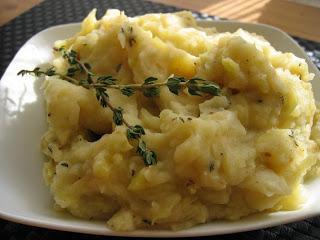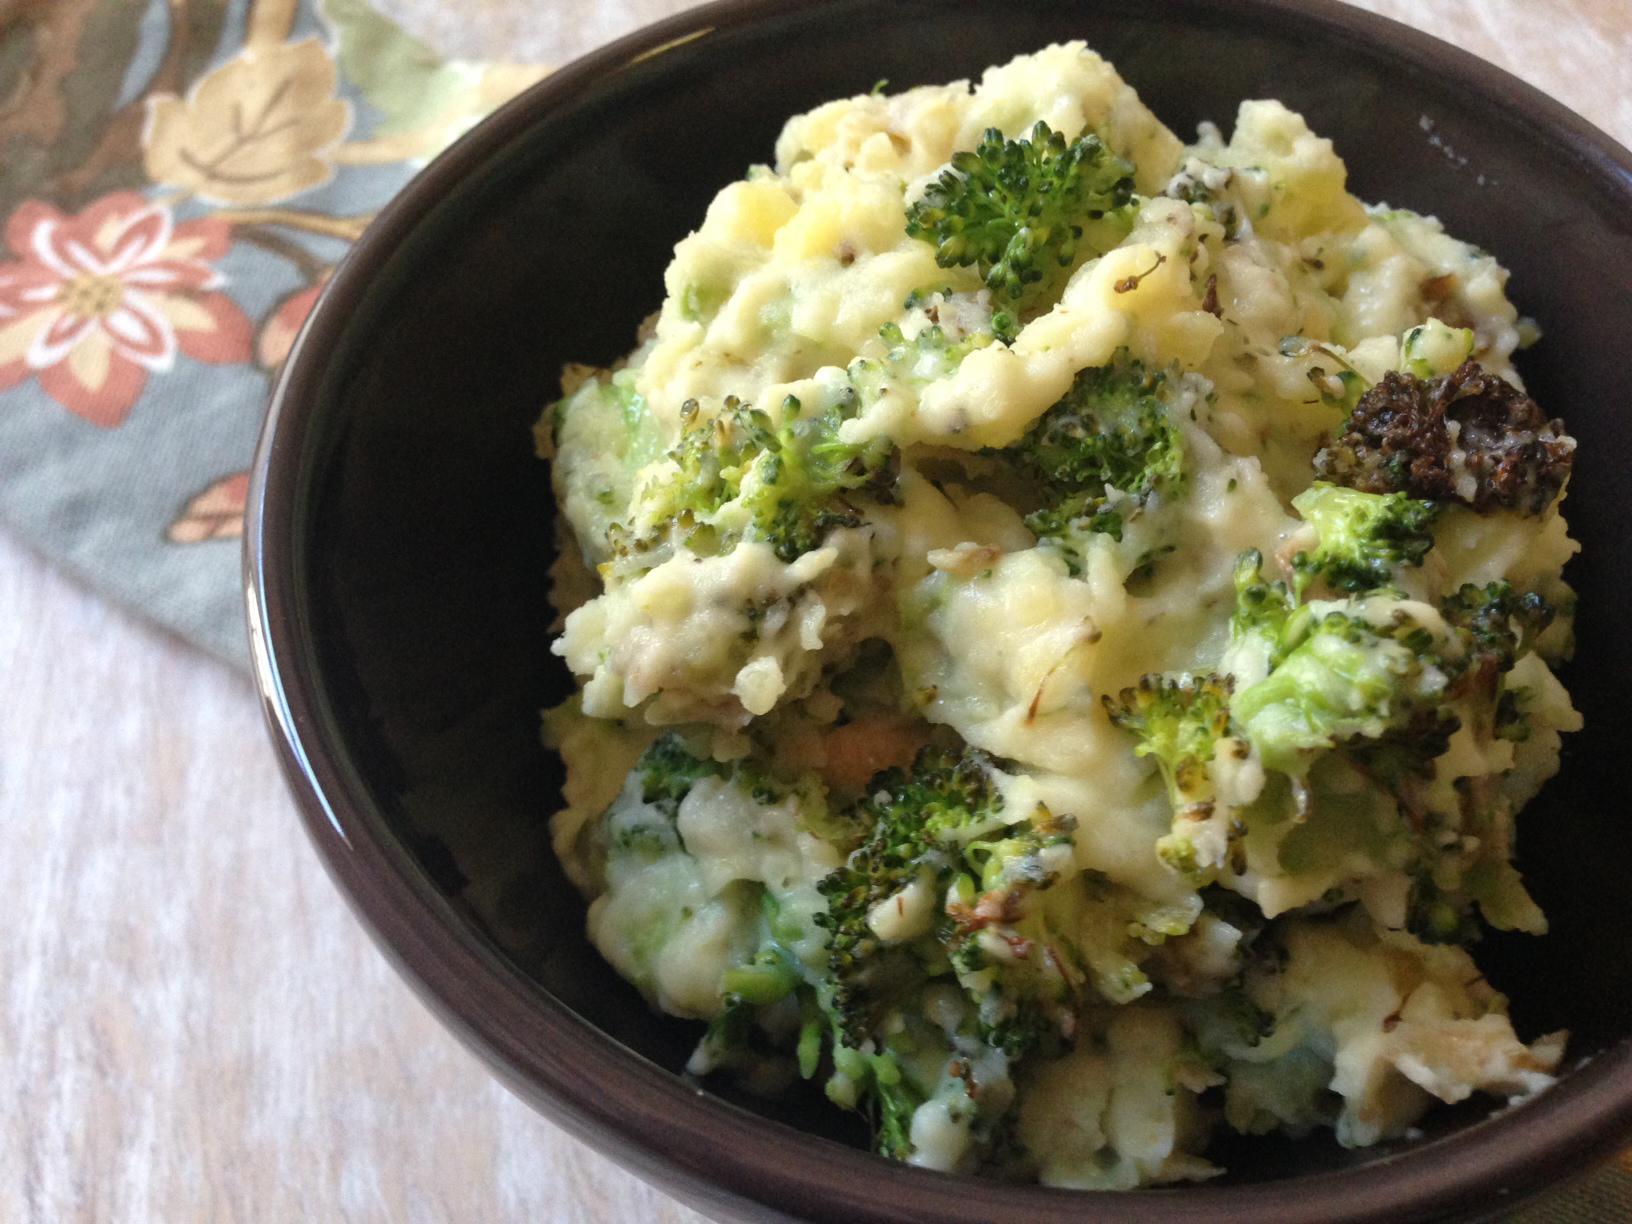The first image is the image on the left, the second image is the image on the right. Examine the images to the left and right. Is the description "One serving of mashed potatoes is garnished with a pat of butter." accurate? Answer yes or no. No. 